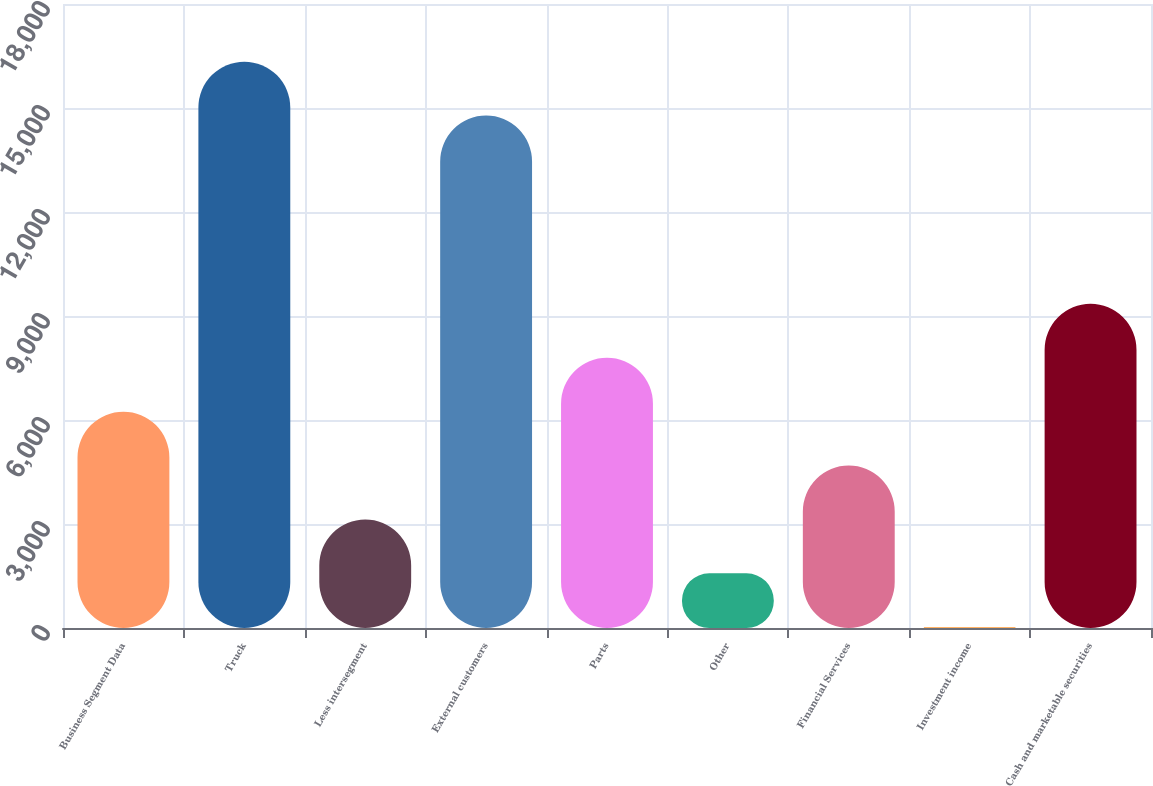Convert chart. <chart><loc_0><loc_0><loc_500><loc_500><bar_chart><fcel>Business Segment Data<fcel>Truck<fcel>Less intersegment<fcel>External customers<fcel>Parts<fcel>Other<fcel>Financial Services<fcel>Investment income<fcel>Cash and marketable securities<nl><fcel>6240.52<fcel>16337.2<fcel>3131.16<fcel>14782.5<fcel>7795.2<fcel>1576.48<fcel>4685.84<fcel>21.8<fcel>9349.88<nl></chart> 